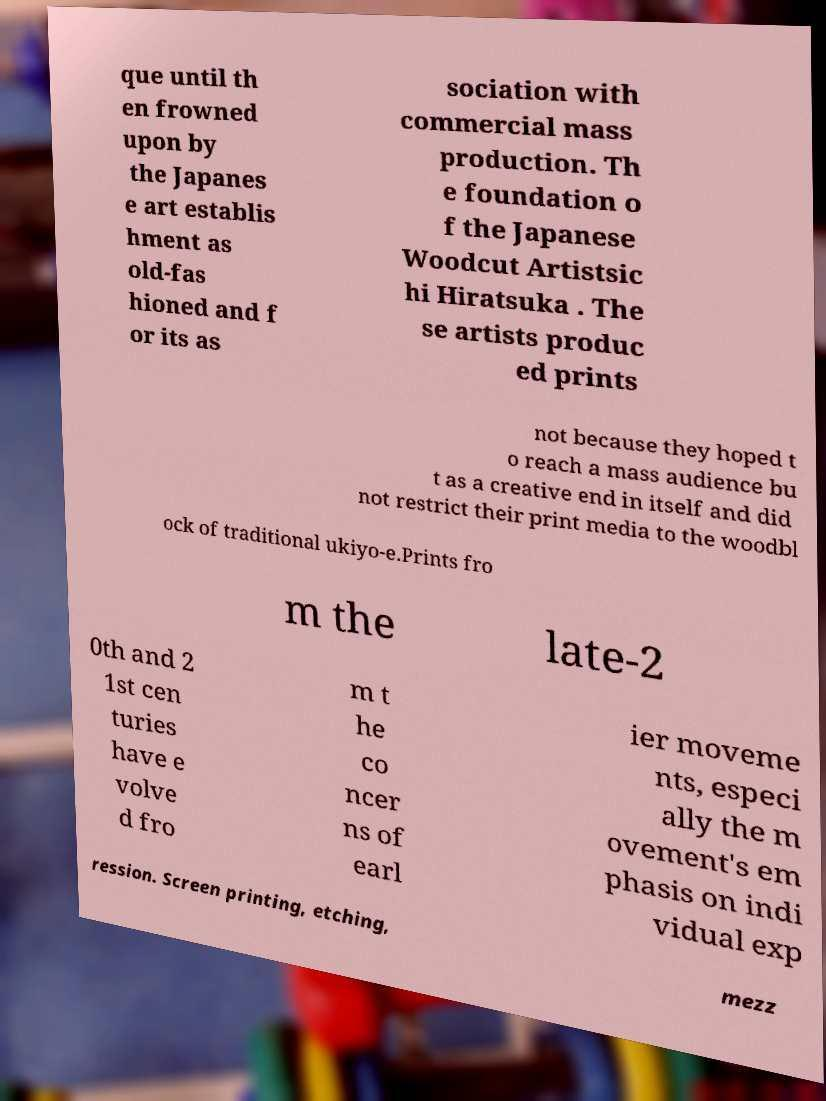Could you extract and type out the text from this image? que until th en frowned upon by the Japanes e art establis hment as old-fas hioned and f or its as sociation with commercial mass production. Th e foundation o f the Japanese Woodcut Artistsic hi Hiratsuka . The se artists produc ed prints not because they hoped t o reach a mass audience bu t as a creative end in itself and did not restrict their print media to the woodbl ock of traditional ukiyo-e.Prints fro m the late-2 0th and 2 1st cen turies have e volve d fro m t he co ncer ns of earl ier moveme nts, especi ally the m ovement's em phasis on indi vidual exp ression. Screen printing, etching, mezz 